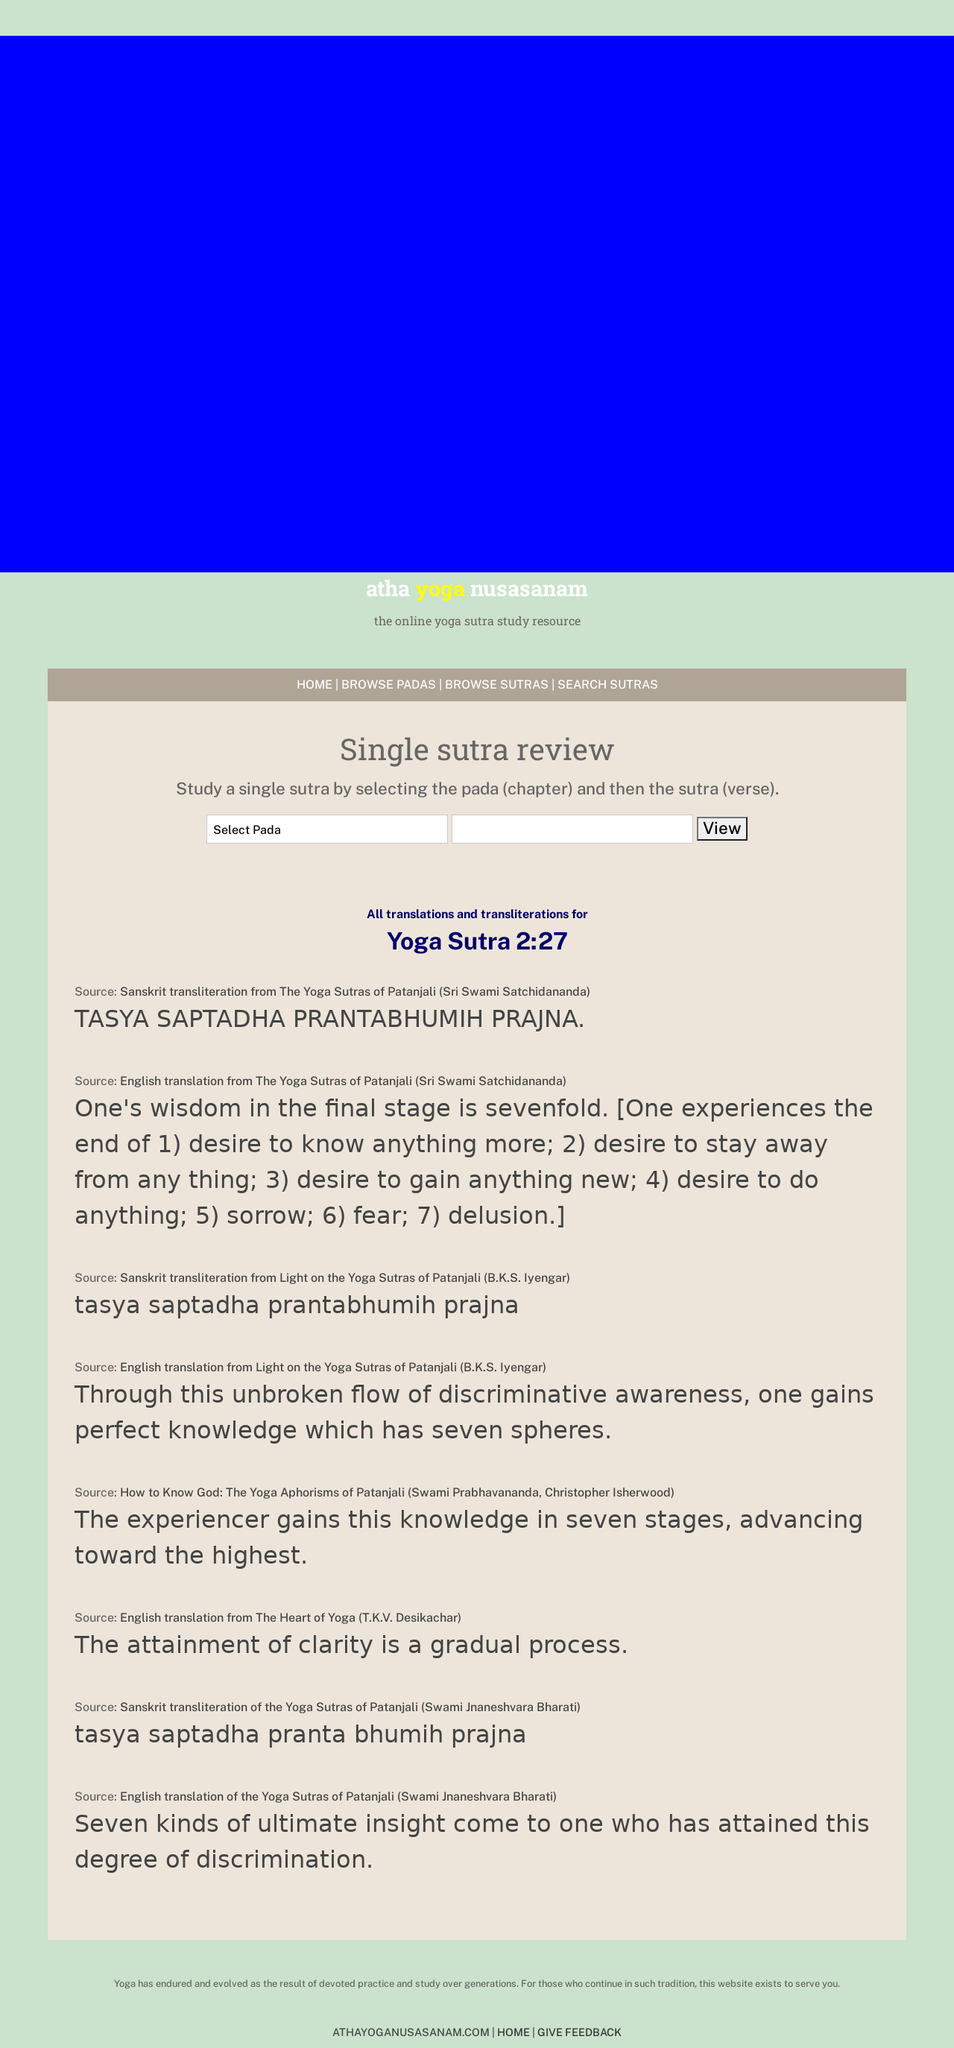How can I start building this website with HTML from the ground up? To start building a website from scratch using HTML, you should begin by setting up the basic structure with a DOCTYPE declaration, followed by specifying the html element with attributes like language and character encoding in the head section. Include essential meta tags for responsiveness and compatibility. In the body section, you can start adding content and structuring your web pages using div tags. Here's an example of a basic HTML template: <!DOCTYPE html><html lang='en'><head><meta charset='UTF-8'><meta name='viewport' content='width=device-width, initial-scale=1.0'><title>Your Website Title Here</title></head><body><h1>Welcome to My Website</h1><p>This is a paragraph of text to get started.</p></body></html>. This template provides a solid foundation for further development and customization of your website. 